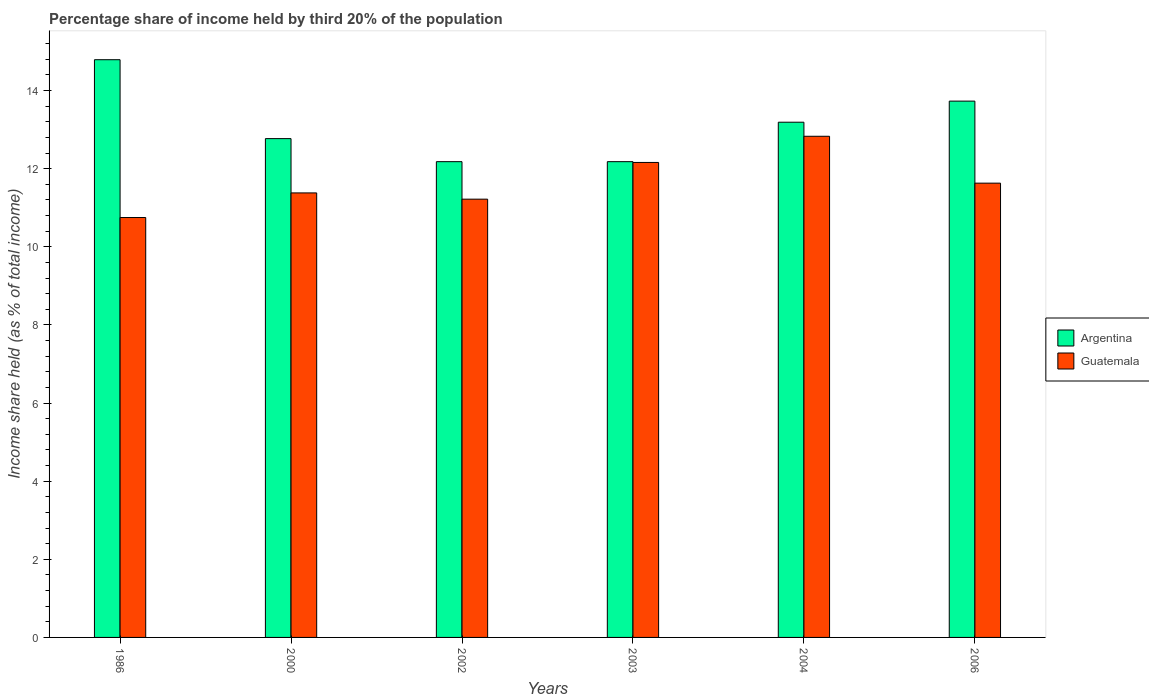How many different coloured bars are there?
Give a very brief answer. 2. Are the number of bars per tick equal to the number of legend labels?
Ensure brevity in your answer.  Yes. How many bars are there on the 2nd tick from the left?
Provide a succinct answer. 2. In how many cases, is the number of bars for a given year not equal to the number of legend labels?
Provide a succinct answer. 0. What is the share of income held by third 20% of the population in Guatemala in 2000?
Ensure brevity in your answer.  11.38. Across all years, what is the maximum share of income held by third 20% of the population in Guatemala?
Your answer should be very brief. 12.83. Across all years, what is the minimum share of income held by third 20% of the population in Argentina?
Give a very brief answer. 12.18. In which year was the share of income held by third 20% of the population in Guatemala maximum?
Your answer should be compact. 2004. In which year was the share of income held by third 20% of the population in Argentina minimum?
Offer a terse response. 2002. What is the total share of income held by third 20% of the population in Guatemala in the graph?
Give a very brief answer. 69.97. What is the difference between the share of income held by third 20% of the population in Argentina in 1986 and that in 2004?
Offer a terse response. 1.6. What is the difference between the share of income held by third 20% of the population in Argentina in 2000 and the share of income held by third 20% of the population in Guatemala in 2002?
Offer a very short reply. 1.55. What is the average share of income held by third 20% of the population in Argentina per year?
Provide a short and direct response. 13.14. In the year 2002, what is the difference between the share of income held by third 20% of the population in Guatemala and share of income held by third 20% of the population in Argentina?
Provide a short and direct response. -0.96. What is the ratio of the share of income held by third 20% of the population in Argentina in 2000 to that in 2002?
Keep it short and to the point. 1.05. Is the share of income held by third 20% of the population in Argentina in 1986 less than that in 2003?
Your response must be concise. No. Is the difference between the share of income held by third 20% of the population in Guatemala in 1986 and 2002 greater than the difference between the share of income held by third 20% of the population in Argentina in 1986 and 2002?
Give a very brief answer. No. What is the difference between the highest and the second highest share of income held by third 20% of the population in Argentina?
Ensure brevity in your answer.  1.06. What is the difference between the highest and the lowest share of income held by third 20% of the population in Argentina?
Ensure brevity in your answer.  2.61. Is the sum of the share of income held by third 20% of the population in Guatemala in 2003 and 2004 greater than the maximum share of income held by third 20% of the population in Argentina across all years?
Your response must be concise. Yes. What does the 2nd bar from the left in 2003 represents?
Make the answer very short. Guatemala. What does the 2nd bar from the right in 1986 represents?
Keep it short and to the point. Argentina. How many bars are there?
Offer a terse response. 12. What is the difference between two consecutive major ticks on the Y-axis?
Your response must be concise. 2. Are the values on the major ticks of Y-axis written in scientific E-notation?
Ensure brevity in your answer.  No. Does the graph contain any zero values?
Provide a succinct answer. No. Does the graph contain grids?
Your response must be concise. No. Where does the legend appear in the graph?
Give a very brief answer. Center right. How many legend labels are there?
Give a very brief answer. 2. What is the title of the graph?
Offer a very short reply. Percentage share of income held by third 20% of the population. What is the label or title of the X-axis?
Your response must be concise. Years. What is the label or title of the Y-axis?
Your response must be concise. Income share held (as % of total income). What is the Income share held (as % of total income) of Argentina in 1986?
Your answer should be compact. 14.79. What is the Income share held (as % of total income) in Guatemala in 1986?
Ensure brevity in your answer.  10.75. What is the Income share held (as % of total income) in Argentina in 2000?
Your response must be concise. 12.77. What is the Income share held (as % of total income) in Guatemala in 2000?
Make the answer very short. 11.38. What is the Income share held (as % of total income) of Argentina in 2002?
Your response must be concise. 12.18. What is the Income share held (as % of total income) of Guatemala in 2002?
Your answer should be very brief. 11.22. What is the Income share held (as % of total income) in Argentina in 2003?
Provide a short and direct response. 12.18. What is the Income share held (as % of total income) in Guatemala in 2003?
Keep it short and to the point. 12.16. What is the Income share held (as % of total income) in Argentina in 2004?
Offer a terse response. 13.19. What is the Income share held (as % of total income) of Guatemala in 2004?
Provide a succinct answer. 12.83. What is the Income share held (as % of total income) in Argentina in 2006?
Give a very brief answer. 13.73. What is the Income share held (as % of total income) in Guatemala in 2006?
Your answer should be very brief. 11.63. Across all years, what is the maximum Income share held (as % of total income) in Argentina?
Provide a succinct answer. 14.79. Across all years, what is the maximum Income share held (as % of total income) in Guatemala?
Offer a terse response. 12.83. Across all years, what is the minimum Income share held (as % of total income) in Argentina?
Give a very brief answer. 12.18. Across all years, what is the minimum Income share held (as % of total income) in Guatemala?
Make the answer very short. 10.75. What is the total Income share held (as % of total income) of Argentina in the graph?
Provide a succinct answer. 78.84. What is the total Income share held (as % of total income) of Guatemala in the graph?
Your response must be concise. 69.97. What is the difference between the Income share held (as % of total income) of Argentina in 1986 and that in 2000?
Keep it short and to the point. 2.02. What is the difference between the Income share held (as % of total income) of Guatemala in 1986 and that in 2000?
Provide a short and direct response. -0.63. What is the difference between the Income share held (as % of total income) of Argentina in 1986 and that in 2002?
Your answer should be compact. 2.61. What is the difference between the Income share held (as % of total income) in Guatemala in 1986 and that in 2002?
Offer a very short reply. -0.47. What is the difference between the Income share held (as % of total income) in Argentina in 1986 and that in 2003?
Make the answer very short. 2.61. What is the difference between the Income share held (as % of total income) in Guatemala in 1986 and that in 2003?
Provide a succinct answer. -1.41. What is the difference between the Income share held (as % of total income) in Guatemala in 1986 and that in 2004?
Provide a succinct answer. -2.08. What is the difference between the Income share held (as % of total income) in Argentina in 1986 and that in 2006?
Provide a short and direct response. 1.06. What is the difference between the Income share held (as % of total income) of Guatemala in 1986 and that in 2006?
Provide a succinct answer. -0.88. What is the difference between the Income share held (as % of total income) in Argentina in 2000 and that in 2002?
Your answer should be very brief. 0.59. What is the difference between the Income share held (as % of total income) in Guatemala in 2000 and that in 2002?
Your response must be concise. 0.16. What is the difference between the Income share held (as % of total income) in Argentina in 2000 and that in 2003?
Your response must be concise. 0.59. What is the difference between the Income share held (as % of total income) of Guatemala in 2000 and that in 2003?
Your response must be concise. -0.78. What is the difference between the Income share held (as % of total income) of Argentina in 2000 and that in 2004?
Provide a succinct answer. -0.42. What is the difference between the Income share held (as % of total income) in Guatemala in 2000 and that in 2004?
Offer a very short reply. -1.45. What is the difference between the Income share held (as % of total income) of Argentina in 2000 and that in 2006?
Provide a short and direct response. -0.96. What is the difference between the Income share held (as % of total income) of Argentina in 2002 and that in 2003?
Provide a succinct answer. 0. What is the difference between the Income share held (as % of total income) in Guatemala in 2002 and that in 2003?
Give a very brief answer. -0.94. What is the difference between the Income share held (as % of total income) in Argentina in 2002 and that in 2004?
Give a very brief answer. -1.01. What is the difference between the Income share held (as % of total income) in Guatemala in 2002 and that in 2004?
Make the answer very short. -1.61. What is the difference between the Income share held (as % of total income) in Argentina in 2002 and that in 2006?
Offer a terse response. -1.55. What is the difference between the Income share held (as % of total income) in Guatemala in 2002 and that in 2006?
Keep it short and to the point. -0.41. What is the difference between the Income share held (as % of total income) in Argentina in 2003 and that in 2004?
Give a very brief answer. -1.01. What is the difference between the Income share held (as % of total income) of Guatemala in 2003 and that in 2004?
Your response must be concise. -0.67. What is the difference between the Income share held (as % of total income) in Argentina in 2003 and that in 2006?
Keep it short and to the point. -1.55. What is the difference between the Income share held (as % of total income) in Guatemala in 2003 and that in 2006?
Provide a short and direct response. 0.53. What is the difference between the Income share held (as % of total income) of Argentina in 2004 and that in 2006?
Your answer should be compact. -0.54. What is the difference between the Income share held (as % of total income) of Guatemala in 2004 and that in 2006?
Your response must be concise. 1.2. What is the difference between the Income share held (as % of total income) of Argentina in 1986 and the Income share held (as % of total income) of Guatemala in 2000?
Offer a terse response. 3.41. What is the difference between the Income share held (as % of total income) in Argentina in 1986 and the Income share held (as % of total income) in Guatemala in 2002?
Offer a terse response. 3.57. What is the difference between the Income share held (as % of total income) in Argentina in 1986 and the Income share held (as % of total income) in Guatemala in 2003?
Your response must be concise. 2.63. What is the difference between the Income share held (as % of total income) of Argentina in 1986 and the Income share held (as % of total income) of Guatemala in 2004?
Provide a short and direct response. 1.96. What is the difference between the Income share held (as % of total income) of Argentina in 1986 and the Income share held (as % of total income) of Guatemala in 2006?
Make the answer very short. 3.16. What is the difference between the Income share held (as % of total income) in Argentina in 2000 and the Income share held (as % of total income) in Guatemala in 2002?
Your answer should be compact. 1.55. What is the difference between the Income share held (as % of total income) of Argentina in 2000 and the Income share held (as % of total income) of Guatemala in 2003?
Make the answer very short. 0.61. What is the difference between the Income share held (as % of total income) in Argentina in 2000 and the Income share held (as % of total income) in Guatemala in 2004?
Ensure brevity in your answer.  -0.06. What is the difference between the Income share held (as % of total income) in Argentina in 2000 and the Income share held (as % of total income) in Guatemala in 2006?
Ensure brevity in your answer.  1.14. What is the difference between the Income share held (as % of total income) in Argentina in 2002 and the Income share held (as % of total income) in Guatemala in 2004?
Ensure brevity in your answer.  -0.65. What is the difference between the Income share held (as % of total income) in Argentina in 2002 and the Income share held (as % of total income) in Guatemala in 2006?
Offer a terse response. 0.55. What is the difference between the Income share held (as % of total income) in Argentina in 2003 and the Income share held (as % of total income) in Guatemala in 2004?
Keep it short and to the point. -0.65. What is the difference between the Income share held (as % of total income) of Argentina in 2003 and the Income share held (as % of total income) of Guatemala in 2006?
Provide a short and direct response. 0.55. What is the difference between the Income share held (as % of total income) in Argentina in 2004 and the Income share held (as % of total income) in Guatemala in 2006?
Make the answer very short. 1.56. What is the average Income share held (as % of total income) of Argentina per year?
Your answer should be very brief. 13.14. What is the average Income share held (as % of total income) in Guatemala per year?
Provide a short and direct response. 11.66. In the year 1986, what is the difference between the Income share held (as % of total income) in Argentina and Income share held (as % of total income) in Guatemala?
Offer a very short reply. 4.04. In the year 2000, what is the difference between the Income share held (as % of total income) of Argentina and Income share held (as % of total income) of Guatemala?
Your answer should be very brief. 1.39. In the year 2003, what is the difference between the Income share held (as % of total income) in Argentina and Income share held (as % of total income) in Guatemala?
Provide a short and direct response. 0.02. In the year 2004, what is the difference between the Income share held (as % of total income) in Argentina and Income share held (as % of total income) in Guatemala?
Ensure brevity in your answer.  0.36. In the year 2006, what is the difference between the Income share held (as % of total income) in Argentina and Income share held (as % of total income) in Guatemala?
Keep it short and to the point. 2.1. What is the ratio of the Income share held (as % of total income) of Argentina in 1986 to that in 2000?
Provide a succinct answer. 1.16. What is the ratio of the Income share held (as % of total income) of Guatemala in 1986 to that in 2000?
Ensure brevity in your answer.  0.94. What is the ratio of the Income share held (as % of total income) in Argentina in 1986 to that in 2002?
Provide a succinct answer. 1.21. What is the ratio of the Income share held (as % of total income) in Guatemala in 1986 to that in 2002?
Ensure brevity in your answer.  0.96. What is the ratio of the Income share held (as % of total income) in Argentina in 1986 to that in 2003?
Give a very brief answer. 1.21. What is the ratio of the Income share held (as % of total income) in Guatemala in 1986 to that in 2003?
Provide a succinct answer. 0.88. What is the ratio of the Income share held (as % of total income) of Argentina in 1986 to that in 2004?
Offer a terse response. 1.12. What is the ratio of the Income share held (as % of total income) in Guatemala in 1986 to that in 2004?
Offer a very short reply. 0.84. What is the ratio of the Income share held (as % of total income) of Argentina in 1986 to that in 2006?
Offer a terse response. 1.08. What is the ratio of the Income share held (as % of total income) of Guatemala in 1986 to that in 2006?
Your answer should be very brief. 0.92. What is the ratio of the Income share held (as % of total income) in Argentina in 2000 to that in 2002?
Provide a succinct answer. 1.05. What is the ratio of the Income share held (as % of total income) of Guatemala in 2000 to that in 2002?
Your answer should be very brief. 1.01. What is the ratio of the Income share held (as % of total income) of Argentina in 2000 to that in 2003?
Your response must be concise. 1.05. What is the ratio of the Income share held (as % of total income) in Guatemala in 2000 to that in 2003?
Your answer should be compact. 0.94. What is the ratio of the Income share held (as % of total income) of Argentina in 2000 to that in 2004?
Your response must be concise. 0.97. What is the ratio of the Income share held (as % of total income) in Guatemala in 2000 to that in 2004?
Give a very brief answer. 0.89. What is the ratio of the Income share held (as % of total income) of Argentina in 2000 to that in 2006?
Offer a terse response. 0.93. What is the ratio of the Income share held (as % of total income) of Guatemala in 2000 to that in 2006?
Provide a short and direct response. 0.98. What is the ratio of the Income share held (as % of total income) of Guatemala in 2002 to that in 2003?
Provide a short and direct response. 0.92. What is the ratio of the Income share held (as % of total income) in Argentina in 2002 to that in 2004?
Your answer should be very brief. 0.92. What is the ratio of the Income share held (as % of total income) of Guatemala in 2002 to that in 2004?
Make the answer very short. 0.87. What is the ratio of the Income share held (as % of total income) in Argentina in 2002 to that in 2006?
Provide a succinct answer. 0.89. What is the ratio of the Income share held (as % of total income) of Guatemala in 2002 to that in 2006?
Give a very brief answer. 0.96. What is the ratio of the Income share held (as % of total income) in Argentina in 2003 to that in 2004?
Provide a succinct answer. 0.92. What is the ratio of the Income share held (as % of total income) of Guatemala in 2003 to that in 2004?
Make the answer very short. 0.95. What is the ratio of the Income share held (as % of total income) of Argentina in 2003 to that in 2006?
Give a very brief answer. 0.89. What is the ratio of the Income share held (as % of total income) in Guatemala in 2003 to that in 2006?
Ensure brevity in your answer.  1.05. What is the ratio of the Income share held (as % of total income) in Argentina in 2004 to that in 2006?
Provide a succinct answer. 0.96. What is the ratio of the Income share held (as % of total income) of Guatemala in 2004 to that in 2006?
Make the answer very short. 1.1. What is the difference between the highest and the second highest Income share held (as % of total income) of Argentina?
Your answer should be compact. 1.06. What is the difference between the highest and the second highest Income share held (as % of total income) of Guatemala?
Your answer should be very brief. 0.67. What is the difference between the highest and the lowest Income share held (as % of total income) in Argentina?
Offer a very short reply. 2.61. What is the difference between the highest and the lowest Income share held (as % of total income) of Guatemala?
Your response must be concise. 2.08. 